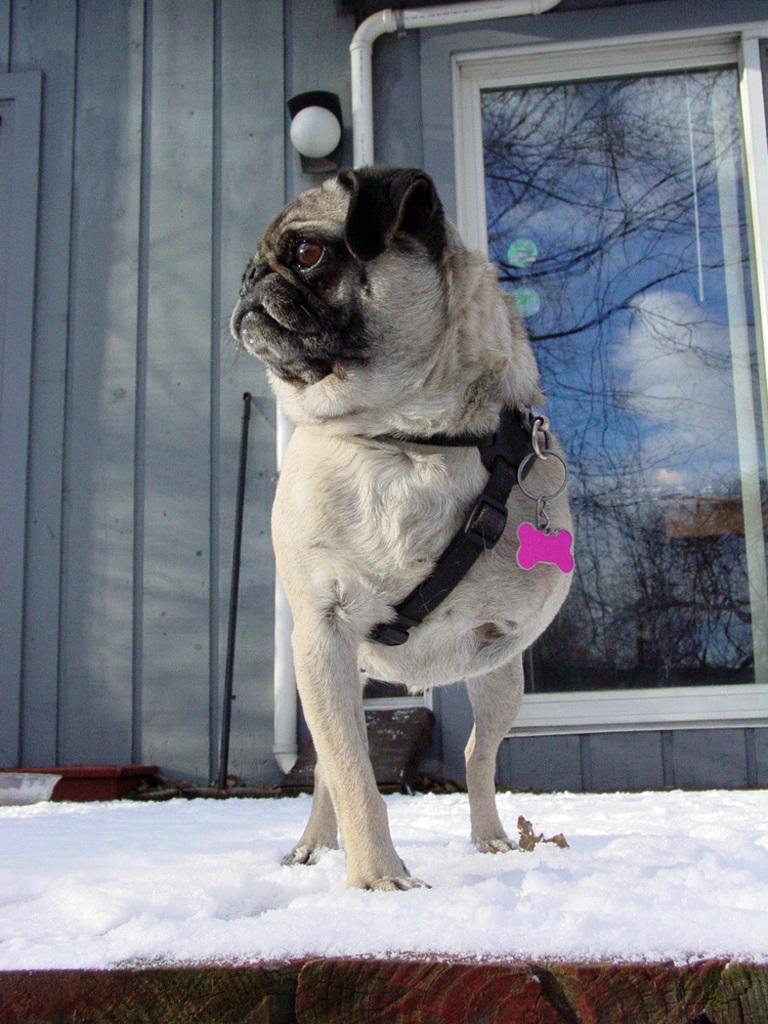Describe this image in one or two sentences. There is a dog with a belt is standing on the snow. In the back there is a wall and a window. On the window there is a reflection of sky with clouds. 